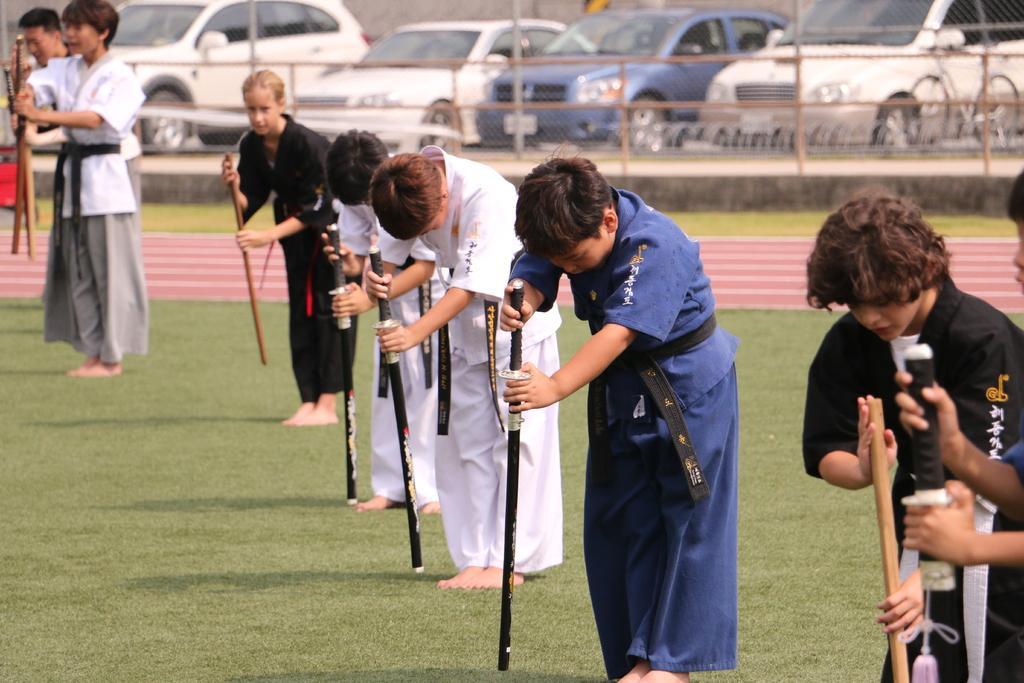Can you describe this image briefly? Here we can see few persons standing on the ground by holding sticks in their hands. In the background we can see a fence,grass,vehicles and a bicycle. 